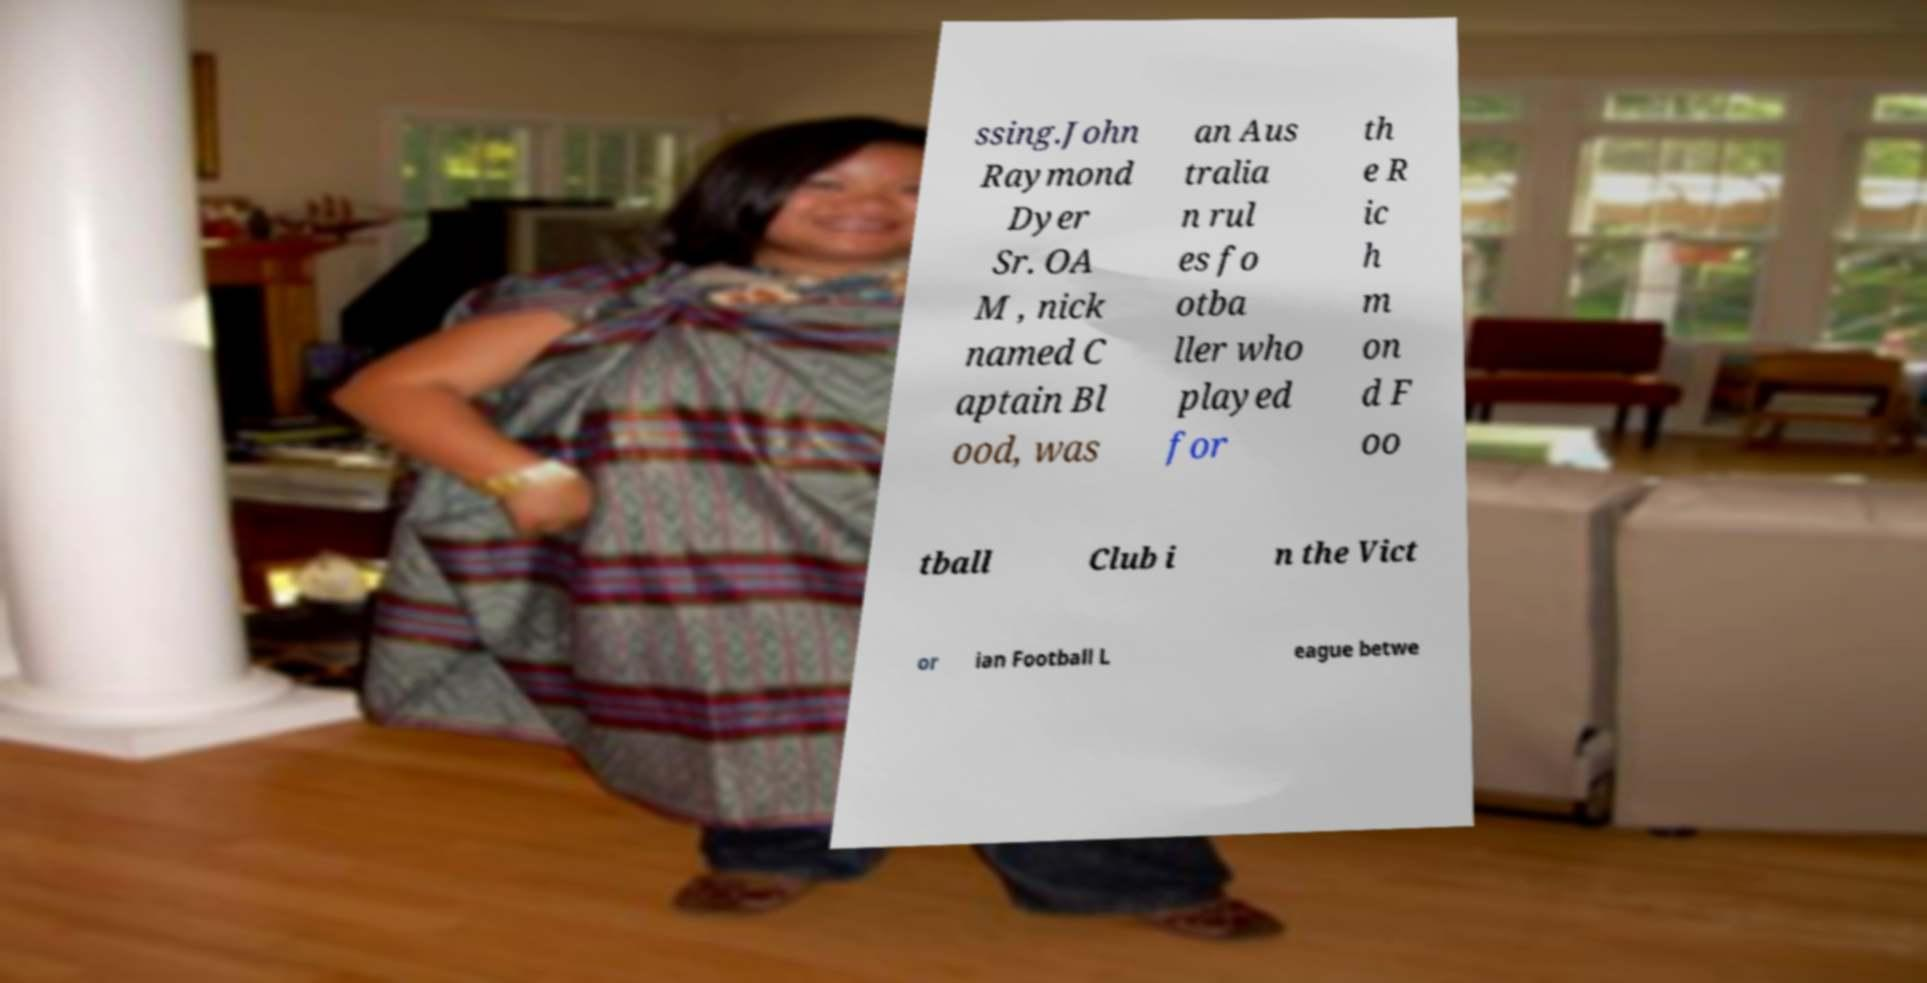There's text embedded in this image that I need extracted. Can you transcribe it verbatim? ssing.John Raymond Dyer Sr. OA M , nick named C aptain Bl ood, was an Aus tralia n rul es fo otba ller who played for th e R ic h m on d F oo tball Club i n the Vict or ian Football L eague betwe 